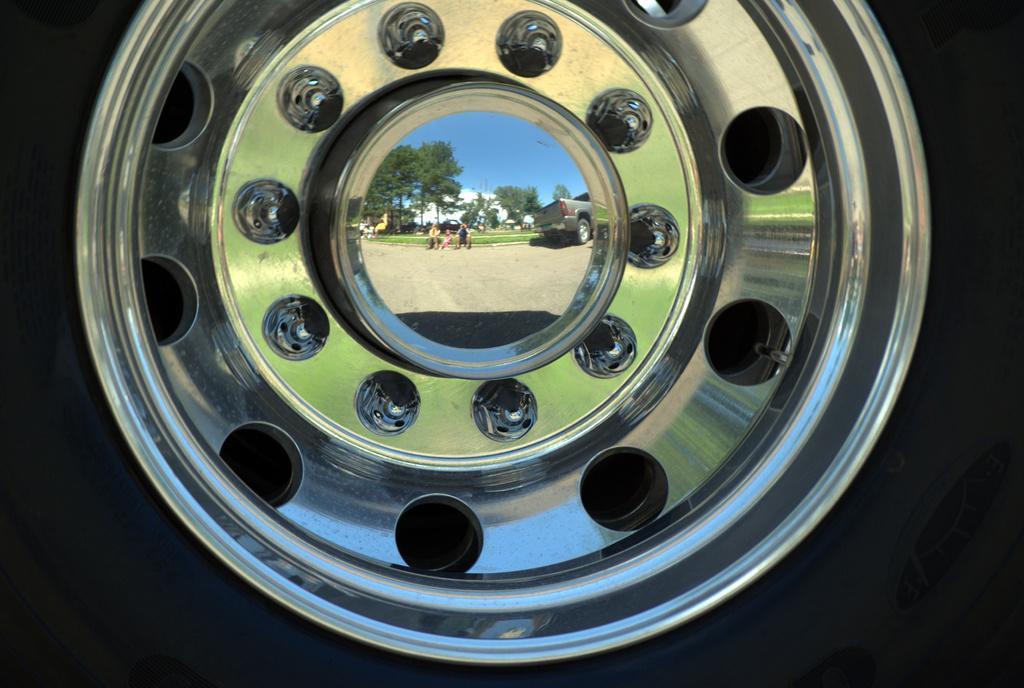Please provide a concise description of this image. In this image we can see Rim wheel of a car in which we can see the reflection of some persons sitting on ground, a vehicle moving, there are some trees and clear sky. 